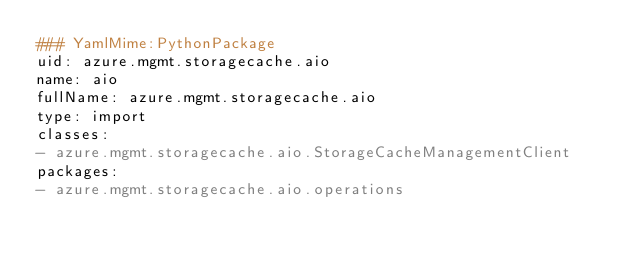Convert code to text. <code><loc_0><loc_0><loc_500><loc_500><_YAML_>### YamlMime:PythonPackage
uid: azure.mgmt.storagecache.aio
name: aio
fullName: azure.mgmt.storagecache.aio
type: import
classes:
- azure.mgmt.storagecache.aio.StorageCacheManagementClient
packages:
- azure.mgmt.storagecache.aio.operations
</code> 